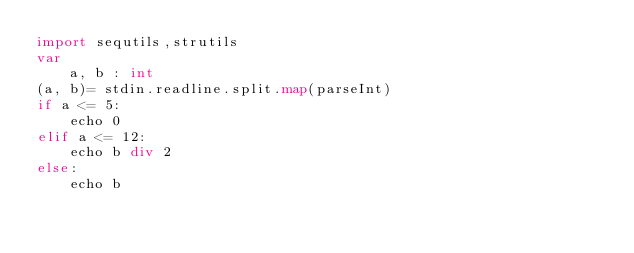Convert code to text. <code><loc_0><loc_0><loc_500><loc_500><_Nim_>import sequtils,strutils
var
    a, b : int
(a, b)= stdin.readline.split.map(parseInt)
if a <= 5:
    echo 0
elif a <= 12:
    echo b div 2
else:
    echo b</code> 